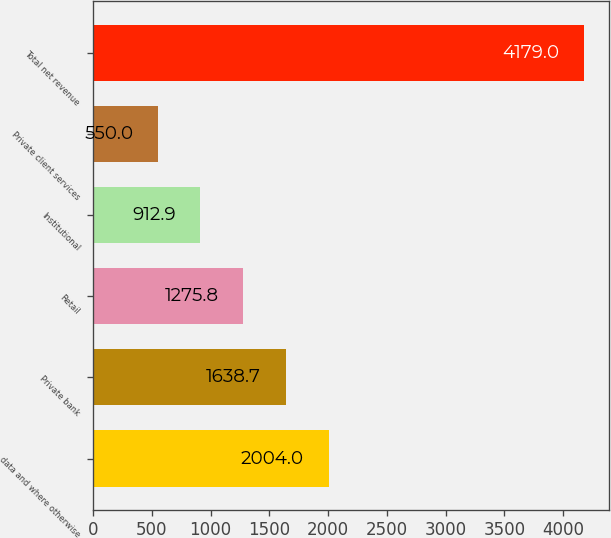Convert chart to OTSL. <chart><loc_0><loc_0><loc_500><loc_500><bar_chart><fcel>data and where otherwise<fcel>Private bank<fcel>Retail<fcel>Institutional<fcel>Private client services<fcel>Total net revenue<nl><fcel>2004<fcel>1638.7<fcel>1275.8<fcel>912.9<fcel>550<fcel>4179<nl></chart> 